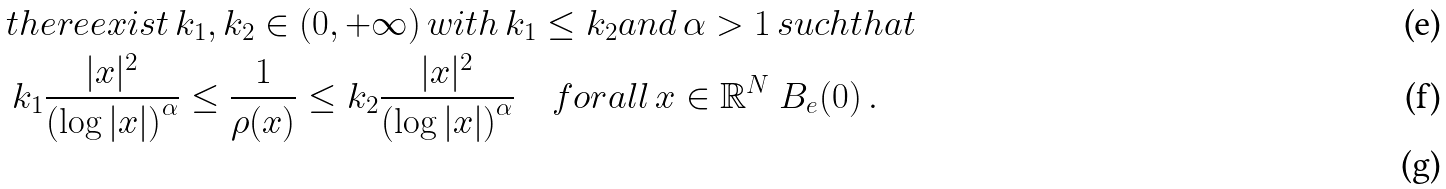<formula> <loc_0><loc_0><loc_500><loc_500>& t h e r e e x i s t \, k _ { 1 } , k _ { 2 } \in ( 0 , + \infty ) \, w i t h \, k _ { 1 } \leq k _ { 2 } a n d \, \alpha > 1 \, s u c h t h a t \\ & \, k _ { 1 } \frac { | x | ^ { 2 } } { \left ( \log | x | \right ) ^ { \alpha } } \leq \frac { 1 } { \rho ( x ) } \leq k _ { 2 } \frac { | x | ^ { 2 } } { \left ( \log | x | \right ) ^ { \alpha } } \quad f o r a l l \, x \in \mathbb { R } ^ { N } \ B _ { e } ( 0 ) \, . \\</formula> 